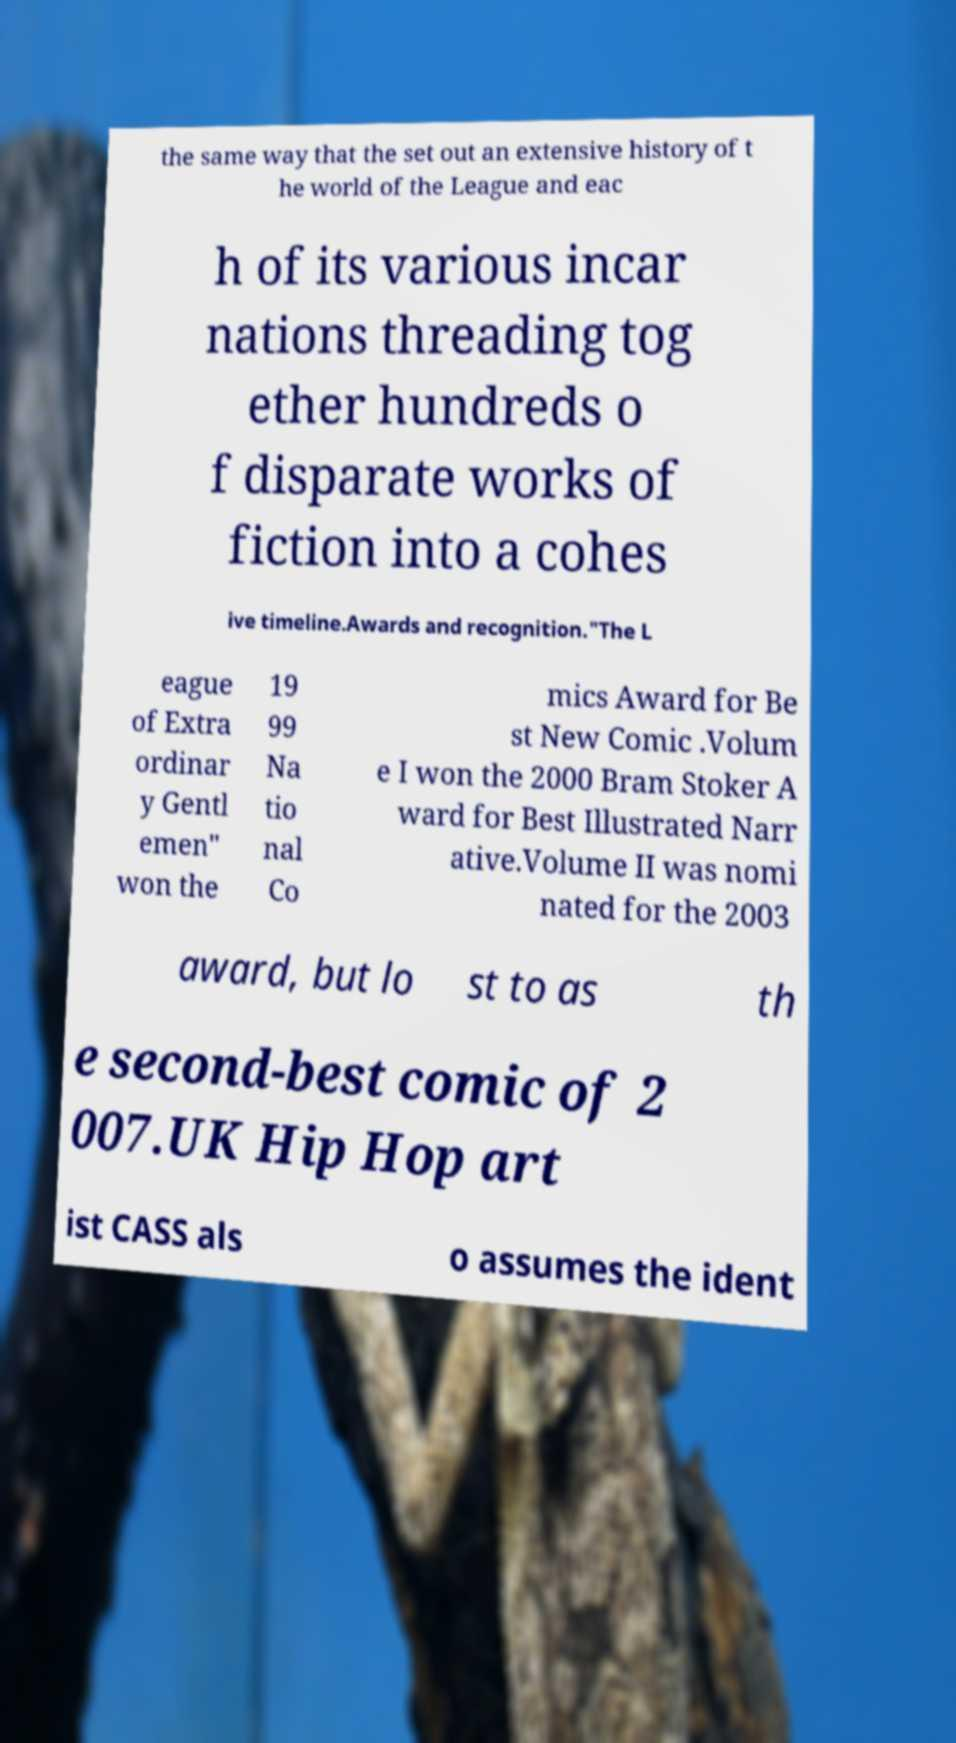Can you accurately transcribe the text from the provided image for me? the same way that the set out an extensive history of t he world of the League and eac h of its various incar nations threading tog ether hundreds o f disparate works of fiction into a cohes ive timeline.Awards and recognition."The L eague of Extra ordinar y Gentl emen" won the 19 99 Na tio nal Co mics Award for Be st New Comic .Volum e I won the 2000 Bram Stoker A ward for Best Illustrated Narr ative.Volume II was nomi nated for the 2003 award, but lo st to as th e second-best comic of 2 007.UK Hip Hop art ist CASS als o assumes the ident 